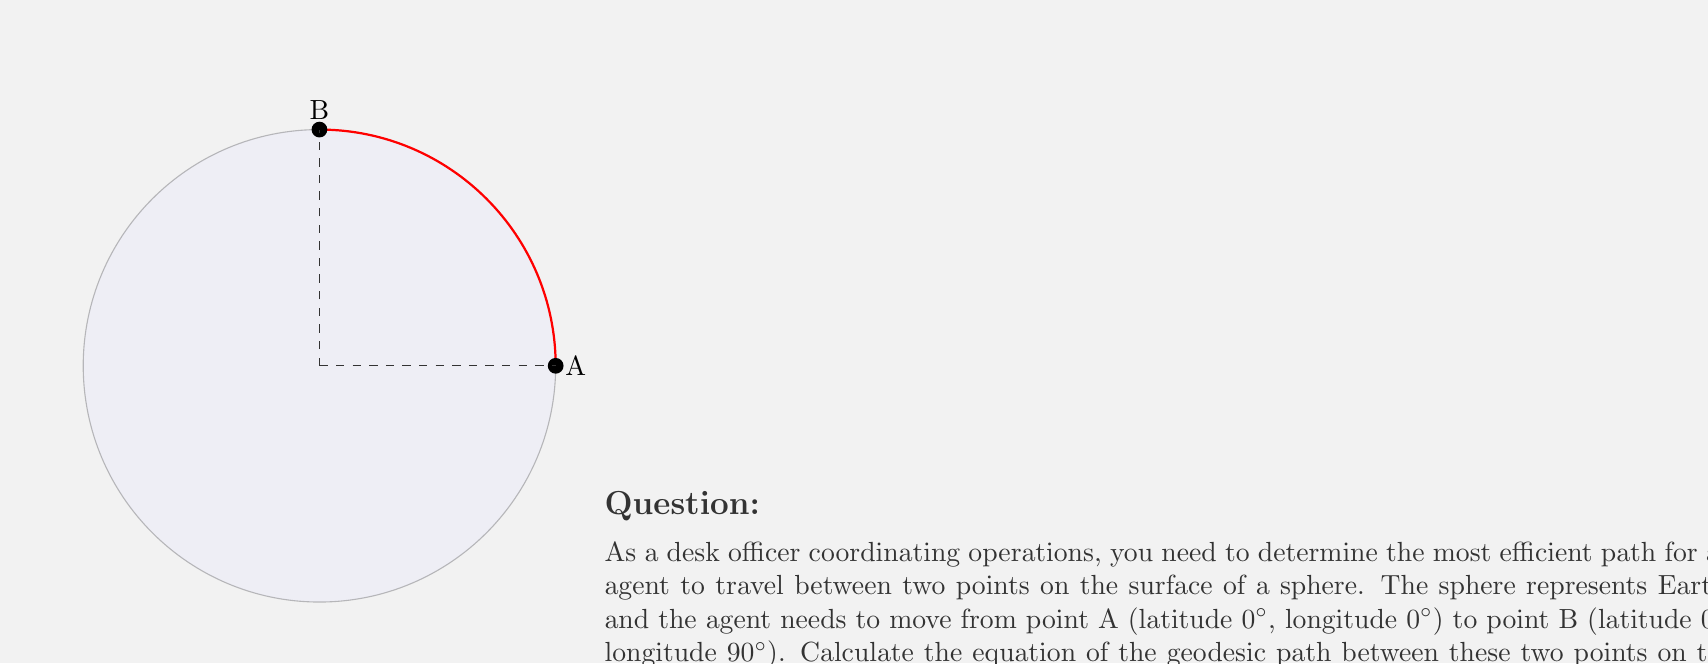Show me your answer to this math problem. To solve this problem, we'll follow these steps:

1) First, recall that on a sphere, the geodesic path between two points is a great circle arc. In this case, it's part of the equator.

2) We can parameterize the sphere using spherical coordinates:
   $$x = R \cos\theta \cos\phi$$
   $$y = R \cos\theta \sin\phi$$
   $$z = R \sin\theta$$
   where $R$ is the radius, $\theta$ is the latitude, and $\phi$ is the longitude.

3) For our path along the equator, $\theta = 0$ (constant). So our parameterization simplifies to:
   $$x = R \cos\phi$$
   $$y = R \sin\phi$$
   $$z = 0$$

4) The parameter $\phi$ will range from 0 to $\pi/2$ (90°) for our path.

5) To get the equation of the geodesic, we can eliminate the parameter:
   $$x^2 + y^2 = R^2$$
   $$z = 0$$

6) This is the equation of a circle in the xy-plane with radius R, intersected with the plane z=0.

7) In vector form, we can write the equation of the geodesic path as:
   $$\vec{r}(t) = R(\cos t, \sin t, 0)$$
   where $0 \leq t \leq \pi/2$

8) The specific radius in this case is 6371 km, so our final equation is:
   $$\vec{r}(t) = 6371(\cos t, \sin t, 0)$$
   where $0 \leq t \leq \pi/2$
Answer: $$\vec{r}(t) = 6371(\cos t, \sin t, 0), 0 \leq t \leq \pi/2$$ 